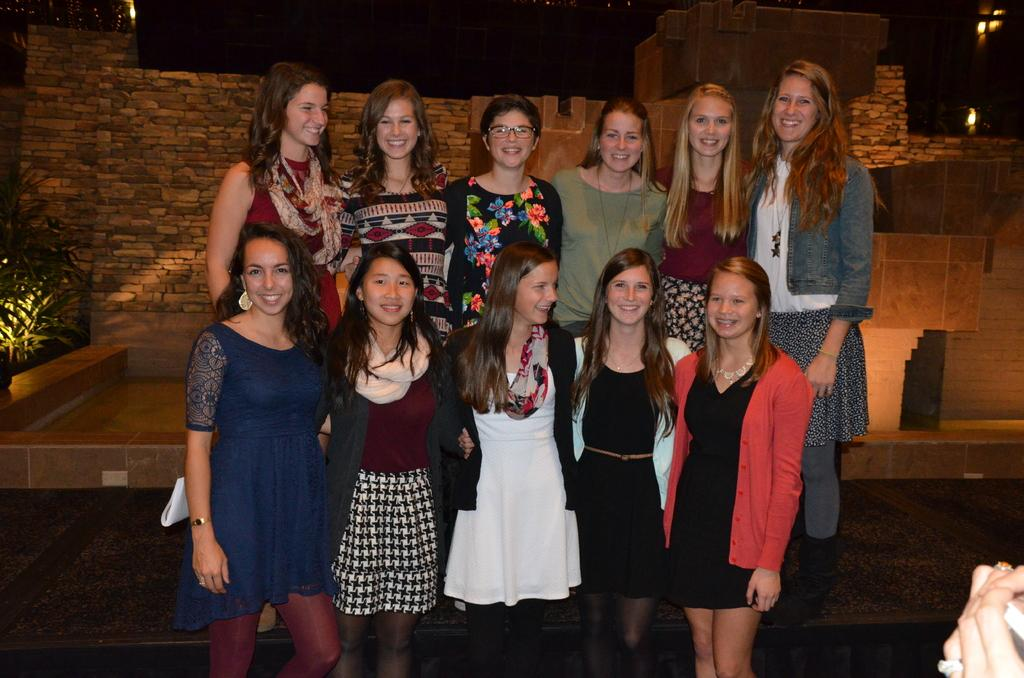What is happening in the image? There is a group of ladies in the image, and they are taking a photograph. How are the ladies positioned in the image? The ladies are standing in two rows. What type of ring can be seen on the finger of the lady in the front row? There is no ring visible on any of the ladies' fingers in the image. What kind of corn is being harvested in the background of the image? There is no corn or any agricultural activity visible in the image; it features a group of ladies standing in two rows. 